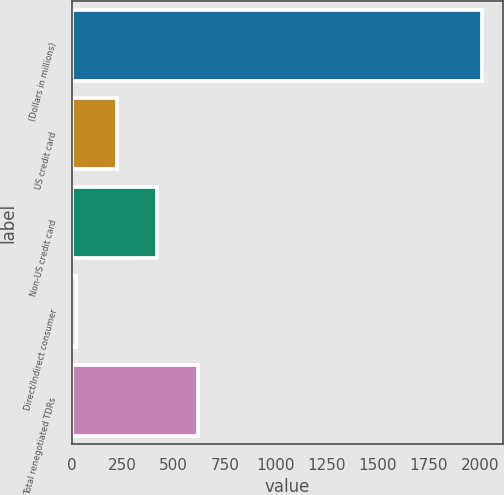<chart> <loc_0><loc_0><loc_500><loc_500><bar_chart><fcel>(Dollars in millions)<fcel>US credit card<fcel>Non-US credit card<fcel>Direct/Indirect consumer<fcel>Total renegotiated TDRs<nl><fcel>2011<fcel>220.9<fcel>419.8<fcel>22<fcel>618.7<nl></chart> 